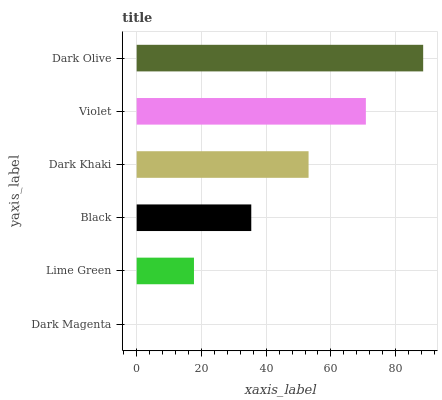Is Dark Magenta the minimum?
Answer yes or no. Yes. Is Dark Olive the maximum?
Answer yes or no. Yes. Is Lime Green the minimum?
Answer yes or no. No. Is Lime Green the maximum?
Answer yes or no. No. Is Lime Green greater than Dark Magenta?
Answer yes or no. Yes. Is Dark Magenta less than Lime Green?
Answer yes or no. Yes. Is Dark Magenta greater than Lime Green?
Answer yes or no. No. Is Lime Green less than Dark Magenta?
Answer yes or no. No. Is Dark Khaki the high median?
Answer yes or no. Yes. Is Black the low median?
Answer yes or no. Yes. Is Dark Magenta the high median?
Answer yes or no. No. Is Dark Magenta the low median?
Answer yes or no. No. 